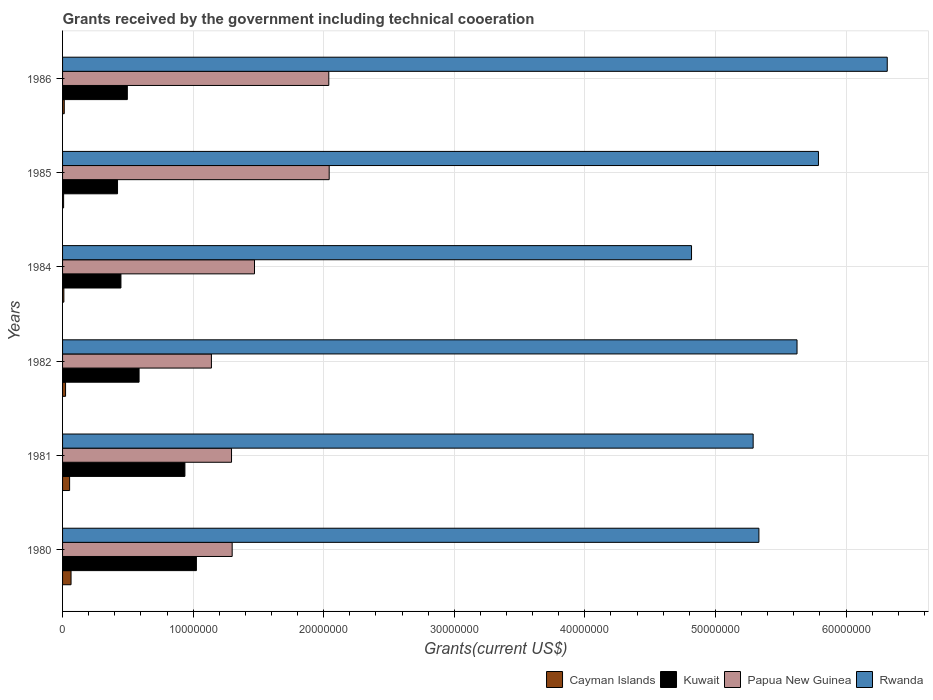Are the number of bars per tick equal to the number of legend labels?
Your response must be concise. Yes. Are the number of bars on each tick of the Y-axis equal?
Provide a short and direct response. Yes. What is the label of the 5th group of bars from the top?
Keep it short and to the point. 1981. What is the total grants received by the government in Rwanda in 1981?
Offer a terse response. 5.29e+07. Across all years, what is the maximum total grants received by the government in Kuwait?
Your answer should be compact. 1.02e+07. Across all years, what is the minimum total grants received by the government in Kuwait?
Provide a succinct answer. 4.21e+06. In which year was the total grants received by the government in Papua New Guinea maximum?
Provide a short and direct response. 1985. What is the total total grants received by the government in Cayman Islands in the graph?
Ensure brevity in your answer.  1.73e+06. What is the difference between the total grants received by the government in Kuwait in 1982 and the total grants received by the government in Cayman Islands in 1986?
Offer a very short reply. 5.73e+06. What is the average total grants received by the government in Cayman Islands per year?
Offer a terse response. 2.88e+05. In the year 1985, what is the difference between the total grants received by the government in Papua New Guinea and total grants received by the government in Kuwait?
Offer a very short reply. 1.62e+07. In how many years, is the total grants received by the government in Papua New Guinea greater than 6000000 US$?
Ensure brevity in your answer.  6. What is the ratio of the total grants received by the government in Cayman Islands in 1980 to that in 1985?
Your answer should be very brief. 8.12. Is the total grants received by the government in Papua New Guinea in 1982 less than that in 1986?
Your response must be concise. Yes. Is the difference between the total grants received by the government in Papua New Guinea in 1980 and 1985 greater than the difference between the total grants received by the government in Kuwait in 1980 and 1985?
Offer a very short reply. No. What is the difference between the highest and the second highest total grants received by the government in Rwanda?
Keep it short and to the point. 5.27e+06. What is the difference between the highest and the lowest total grants received by the government in Rwanda?
Keep it short and to the point. 1.50e+07. In how many years, is the total grants received by the government in Cayman Islands greater than the average total grants received by the government in Cayman Islands taken over all years?
Offer a terse response. 2. What does the 4th bar from the top in 1985 represents?
Offer a very short reply. Cayman Islands. What does the 3rd bar from the bottom in 1986 represents?
Offer a very short reply. Papua New Guinea. Is it the case that in every year, the sum of the total grants received by the government in Rwanda and total grants received by the government in Kuwait is greater than the total grants received by the government in Papua New Guinea?
Ensure brevity in your answer.  Yes. Does the graph contain any zero values?
Ensure brevity in your answer.  No. Does the graph contain grids?
Provide a succinct answer. Yes. Where does the legend appear in the graph?
Your response must be concise. Bottom right. How many legend labels are there?
Keep it short and to the point. 4. How are the legend labels stacked?
Ensure brevity in your answer.  Horizontal. What is the title of the graph?
Offer a very short reply. Grants received by the government including technical cooeration. What is the label or title of the X-axis?
Offer a very short reply. Grants(current US$). What is the Grants(current US$) of Cayman Islands in 1980?
Provide a succinct answer. 6.50e+05. What is the Grants(current US$) in Kuwait in 1980?
Your answer should be very brief. 1.02e+07. What is the Grants(current US$) in Papua New Guinea in 1980?
Offer a very short reply. 1.30e+07. What is the Grants(current US$) in Rwanda in 1980?
Provide a succinct answer. 5.33e+07. What is the Grants(current US$) in Cayman Islands in 1981?
Offer a very short reply. 5.40e+05. What is the Grants(current US$) in Kuwait in 1981?
Offer a terse response. 9.37e+06. What is the Grants(current US$) of Papua New Guinea in 1981?
Keep it short and to the point. 1.29e+07. What is the Grants(current US$) in Rwanda in 1981?
Your answer should be very brief. 5.29e+07. What is the Grants(current US$) in Cayman Islands in 1982?
Make the answer very short. 2.30e+05. What is the Grants(current US$) in Kuwait in 1982?
Keep it short and to the point. 5.86e+06. What is the Grants(current US$) in Papua New Guinea in 1982?
Make the answer very short. 1.14e+07. What is the Grants(current US$) of Rwanda in 1982?
Your answer should be very brief. 5.62e+07. What is the Grants(current US$) of Kuwait in 1984?
Make the answer very short. 4.47e+06. What is the Grants(current US$) of Papua New Guinea in 1984?
Provide a succinct answer. 1.47e+07. What is the Grants(current US$) in Rwanda in 1984?
Offer a terse response. 4.82e+07. What is the Grants(current US$) in Kuwait in 1985?
Offer a very short reply. 4.21e+06. What is the Grants(current US$) in Papua New Guinea in 1985?
Offer a terse response. 2.04e+07. What is the Grants(current US$) of Rwanda in 1985?
Give a very brief answer. 5.79e+07. What is the Grants(current US$) of Kuwait in 1986?
Give a very brief answer. 4.96e+06. What is the Grants(current US$) of Papua New Guinea in 1986?
Keep it short and to the point. 2.04e+07. What is the Grants(current US$) of Rwanda in 1986?
Offer a very short reply. 6.32e+07. Across all years, what is the maximum Grants(current US$) in Cayman Islands?
Your answer should be very brief. 6.50e+05. Across all years, what is the maximum Grants(current US$) in Kuwait?
Your answer should be very brief. 1.02e+07. Across all years, what is the maximum Grants(current US$) in Papua New Guinea?
Offer a very short reply. 2.04e+07. Across all years, what is the maximum Grants(current US$) in Rwanda?
Ensure brevity in your answer.  6.32e+07. Across all years, what is the minimum Grants(current US$) in Kuwait?
Your answer should be very brief. 4.21e+06. Across all years, what is the minimum Grants(current US$) of Papua New Guinea?
Provide a short and direct response. 1.14e+07. Across all years, what is the minimum Grants(current US$) of Rwanda?
Offer a terse response. 4.82e+07. What is the total Grants(current US$) in Cayman Islands in the graph?
Offer a very short reply. 1.73e+06. What is the total Grants(current US$) of Kuwait in the graph?
Your response must be concise. 3.91e+07. What is the total Grants(current US$) of Papua New Guinea in the graph?
Your response must be concise. 9.28e+07. What is the total Grants(current US$) of Rwanda in the graph?
Provide a short and direct response. 3.32e+08. What is the difference between the Grants(current US$) in Kuwait in 1980 and that in 1981?
Ensure brevity in your answer.  8.80e+05. What is the difference between the Grants(current US$) of Cayman Islands in 1980 and that in 1982?
Your answer should be compact. 4.20e+05. What is the difference between the Grants(current US$) of Kuwait in 1980 and that in 1982?
Your answer should be very brief. 4.39e+06. What is the difference between the Grants(current US$) of Papua New Guinea in 1980 and that in 1982?
Provide a short and direct response. 1.59e+06. What is the difference between the Grants(current US$) of Rwanda in 1980 and that in 1982?
Provide a short and direct response. -2.92e+06. What is the difference between the Grants(current US$) in Cayman Islands in 1980 and that in 1984?
Offer a very short reply. 5.50e+05. What is the difference between the Grants(current US$) in Kuwait in 1980 and that in 1984?
Provide a short and direct response. 5.78e+06. What is the difference between the Grants(current US$) of Papua New Guinea in 1980 and that in 1984?
Make the answer very short. -1.71e+06. What is the difference between the Grants(current US$) in Rwanda in 1980 and that in 1984?
Ensure brevity in your answer.  5.16e+06. What is the difference between the Grants(current US$) in Cayman Islands in 1980 and that in 1985?
Offer a very short reply. 5.70e+05. What is the difference between the Grants(current US$) in Kuwait in 1980 and that in 1985?
Your answer should be very brief. 6.04e+06. What is the difference between the Grants(current US$) in Papua New Guinea in 1980 and that in 1985?
Your response must be concise. -7.43e+06. What is the difference between the Grants(current US$) in Rwanda in 1980 and that in 1985?
Provide a short and direct response. -4.56e+06. What is the difference between the Grants(current US$) in Cayman Islands in 1980 and that in 1986?
Offer a very short reply. 5.20e+05. What is the difference between the Grants(current US$) in Kuwait in 1980 and that in 1986?
Your answer should be compact. 5.29e+06. What is the difference between the Grants(current US$) of Papua New Guinea in 1980 and that in 1986?
Provide a short and direct response. -7.40e+06. What is the difference between the Grants(current US$) in Rwanda in 1980 and that in 1986?
Your answer should be very brief. -9.83e+06. What is the difference between the Grants(current US$) in Kuwait in 1981 and that in 1982?
Ensure brevity in your answer.  3.51e+06. What is the difference between the Grants(current US$) in Papua New Guinea in 1981 and that in 1982?
Keep it short and to the point. 1.54e+06. What is the difference between the Grants(current US$) in Rwanda in 1981 and that in 1982?
Your answer should be very brief. -3.36e+06. What is the difference between the Grants(current US$) of Kuwait in 1981 and that in 1984?
Provide a short and direct response. 4.90e+06. What is the difference between the Grants(current US$) of Papua New Guinea in 1981 and that in 1984?
Your answer should be compact. -1.76e+06. What is the difference between the Grants(current US$) of Rwanda in 1981 and that in 1984?
Ensure brevity in your answer.  4.72e+06. What is the difference between the Grants(current US$) of Kuwait in 1981 and that in 1985?
Make the answer very short. 5.16e+06. What is the difference between the Grants(current US$) of Papua New Guinea in 1981 and that in 1985?
Your answer should be very brief. -7.48e+06. What is the difference between the Grants(current US$) in Rwanda in 1981 and that in 1985?
Provide a short and direct response. -5.00e+06. What is the difference between the Grants(current US$) of Cayman Islands in 1981 and that in 1986?
Make the answer very short. 4.10e+05. What is the difference between the Grants(current US$) in Kuwait in 1981 and that in 1986?
Your answer should be very brief. 4.41e+06. What is the difference between the Grants(current US$) in Papua New Guinea in 1981 and that in 1986?
Your answer should be very brief. -7.45e+06. What is the difference between the Grants(current US$) of Rwanda in 1981 and that in 1986?
Your answer should be compact. -1.03e+07. What is the difference between the Grants(current US$) in Cayman Islands in 1982 and that in 1984?
Offer a very short reply. 1.30e+05. What is the difference between the Grants(current US$) of Kuwait in 1982 and that in 1984?
Your answer should be compact. 1.39e+06. What is the difference between the Grants(current US$) of Papua New Guinea in 1982 and that in 1984?
Offer a terse response. -3.30e+06. What is the difference between the Grants(current US$) of Rwanda in 1982 and that in 1984?
Your answer should be very brief. 8.08e+06. What is the difference between the Grants(current US$) in Cayman Islands in 1982 and that in 1985?
Ensure brevity in your answer.  1.50e+05. What is the difference between the Grants(current US$) in Kuwait in 1982 and that in 1985?
Offer a terse response. 1.65e+06. What is the difference between the Grants(current US$) in Papua New Guinea in 1982 and that in 1985?
Provide a succinct answer. -9.02e+06. What is the difference between the Grants(current US$) in Rwanda in 1982 and that in 1985?
Offer a very short reply. -1.64e+06. What is the difference between the Grants(current US$) of Kuwait in 1982 and that in 1986?
Offer a terse response. 9.00e+05. What is the difference between the Grants(current US$) in Papua New Guinea in 1982 and that in 1986?
Offer a very short reply. -8.99e+06. What is the difference between the Grants(current US$) of Rwanda in 1982 and that in 1986?
Offer a very short reply. -6.91e+06. What is the difference between the Grants(current US$) of Papua New Guinea in 1984 and that in 1985?
Provide a succinct answer. -5.72e+06. What is the difference between the Grants(current US$) of Rwanda in 1984 and that in 1985?
Make the answer very short. -9.72e+06. What is the difference between the Grants(current US$) in Kuwait in 1984 and that in 1986?
Provide a short and direct response. -4.90e+05. What is the difference between the Grants(current US$) in Papua New Guinea in 1984 and that in 1986?
Your answer should be compact. -5.69e+06. What is the difference between the Grants(current US$) in Rwanda in 1984 and that in 1986?
Your response must be concise. -1.50e+07. What is the difference between the Grants(current US$) of Cayman Islands in 1985 and that in 1986?
Make the answer very short. -5.00e+04. What is the difference between the Grants(current US$) in Kuwait in 1985 and that in 1986?
Make the answer very short. -7.50e+05. What is the difference between the Grants(current US$) in Rwanda in 1985 and that in 1986?
Make the answer very short. -5.27e+06. What is the difference between the Grants(current US$) in Cayman Islands in 1980 and the Grants(current US$) in Kuwait in 1981?
Offer a very short reply. -8.72e+06. What is the difference between the Grants(current US$) in Cayman Islands in 1980 and the Grants(current US$) in Papua New Guinea in 1981?
Keep it short and to the point. -1.23e+07. What is the difference between the Grants(current US$) in Cayman Islands in 1980 and the Grants(current US$) in Rwanda in 1981?
Provide a succinct answer. -5.22e+07. What is the difference between the Grants(current US$) in Kuwait in 1980 and the Grants(current US$) in Papua New Guinea in 1981?
Give a very brief answer. -2.69e+06. What is the difference between the Grants(current US$) of Kuwait in 1980 and the Grants(current US$) of Rwanda in 1981?
Give a very brief answer. -4.26e+07. What is the difference between the Grants(current US$) of Papua New Guinea in 1980 and the Grants(current US$) of Rwanda in 1981?
Provide a short and direct response. -3.99e+07. What is the difference between the Grants(current US$) of Cayman Islands in 1980 and the Grants(current US$) of Kuwait in 1982?
Provide a short and direct response. -5.21e+06. What is the difference between the Grants(current US$) in Cayman Islands in 1980 and the Grants(current US$) in Papua New Guinea in 1982?
Your response must be concise. -1.08e+07. What is the difference between the Grants(current US$) of Cayman Islands in 1980 and the Grants(current US$) of Rwanda in 1982?
Your answer should be compact. -5.56e+07. What is the difference between the Grants(current US$) of Kuwait in 1980 and the Grants(current US$) of Papua New Guinea in 1982?
Give a very brief answer. -1.15e+06. What is the difference between the Grants(current US$) of Kuwait in 1980 and the Grants(current US$) of Rwanda in 1982?
Your answer should be compact. -4.60e+07. What is the difference between the Grants(current US$) in Papua New Guinea in 1980 and the Grants(current US$) in Rwanda in 1982?
Provide a short and direct response. -4.33e+07. What is the difference between the Grants(current US$) of Cayman Islands in 1980 and the Grants(current US$) of Kuwait in 1984?
Make the answer very short. -3.82e+06. What is the difference between the Grants(current US$) in Cayman Islands in 1980 and the Grants(current US$) in Papua New Guinea in 1984?
Offer a very short reply. -1.40e+07. What is the difference between the Grants(current US$) of Cayman Islands in 1980 and the Grants(current US$) of Rwanda in 1984?
Provide a succinct answer. -4.75e+07. What is the difference between the Grants(current US$) of Kuwait in 1980 and the Grants(current US$) of Papua New Guinea in 1984?
Give a very brief answer. -4.45e+06. What is the difference between the Grants(current US$) in Kuwait in 1980 and the Grants(current US$) in Rwanda in 1984?
Offer a very short reply. -3.79e+07. What is the difference between the Grants(current US$) in Papua New Guinea in 1980 and the Grants(current US$) in Rwanda in 1984?
Your response must be concise. -3.52e+07. What is the difference between the Grants(current US$) of Cayman Islands in 1980 and the Grants(current US$) of Kuwait in 1985?
Provide a short and direct response. -3.56e+06. What is the difference between the Grants(current US$) of Cayman Islands in 1980 and the Grants(current US$) of Papua New Guinea in 1985?
Make the answer very short. -1.98e+07. What is the difference between the Grants(current US$) of Cayman Islands in 1980 and the Grants(current US$) of Rwanda in 1985?
Offer a terse response. -5.72e+07. What is the difference between the Grants(current US$) in Kuwait in 1980 and the Grants(current US$) in Papua New Guinea in 1985?
Your answer should be compact. -1.02e+07. What is the difference between the Grants(current US$) of Kuwait in 1980 and the Grants(current US$) of Rwanda in 1985?
Give a very brief answer. -4.76e+07. What is the difference between the Grants(current US$) in Papua New Guinea in 1980 and the Grants(current US$) in Rwanda in 1985?
Make the answer very short. -4.49e+07. What is the difference between the Grants(current US$) of Cayman Islands in 1980 and the Grants(current US$) of Kuwait in 1986?
Make the answer very short. -4.31e+06. What is the difference between the Grants(current US$) of Cayman Islands in 1980 and the Grants(current US$) of Papua New Guinea in 1986?
Your response must be concise. -1.97e+07. What is the difference between the Grants(current US$) in Cayman Islands in 1980 and the Grants(current US$) in Rwanda in 1986?
Offer a very short reply. -6.25e+07. What is the difference between the Grants(current US$) in Kuwait in 1980 and the Grants(current US$) in Papua New Guinea in 1986?
Give a very brief answer. -1.01e+07. What is the difference between the Grants(current US$) of Kuwait in 1980 and the Grants(current US$) of Rwanda in 1986?
Offer a terse response. -5.29e+07. What is the difference between the Grants(current US$) of Papua New Guinea in 1980 and the Grants(current US$) of Rwanda in 1986?
Provide a succinct answer. -5.02e+07. What is the difference between the Grants(current US$) in Cayman Islands in 1981 and the Grants(current US$) in Kuwait in 1982?
Offer a terse response. -5.32e+06. What is the difference between the Grants(current US$) in Cayman Islands in 1981 and the Grants(current US$) in Papua New Guinea in 1982?
Provide a succinct answer. -1.09e+07. What is the difference between the Grants(current US$) in Cayman Islands in 1981 and the Grants(current US$) in Rwanda in 1982?
Your answer should be very brief. -5.57e+07. What is the difference between the Grants(current US$) in Kuwait in 1981 and the Grants(current US$) in Papua New Guinea in 1982?
Keep it short and to the point. -2.03e+06. What is the difference between the Grants(current US$) of Kuwait in 1981 and the Grants(current US$) of Rwanda in 1982?
Your answer should be very brief. -4.69e+07. What is the difference between the Grants(current US$) in Papua New Guinea in 1981 and the Grants(current US$) in Rwanda in 1982?
Offer a very short reply. -4.33e+07. What is the difference between the Grants(current US$) in Cayman Islands in 1981 and the Grants(current US$) in Kuwait in 1984?
Ensure brevity in your answer.  -3.93e+06. What is the difference between the Grants(current US$) in Cayman Islands in 1981 and the Grants(current US$) in Papua New Guinea in 1984?
Keep it short and to the point. -1.42e+07. What is the difference between the Grants(current US$) of Cayman Islands in 1981 and the Grants(current US$) of Rwanda in 1984?
Your answer should be very brief. -4.76e+07. What is the difference between the Grants(current US$) in Kuwait in 1981 and the Grants(current US$) in Papua New Guinea in 1984?
Offer a terse response. -5.33e+06. What is the difference between the Grants(current US$) of Kuwait in 1981 and the Grants(current US$) of Rwanda in 1984?
Provide a short and direct response. -3.88e+07. What is the difference between the Grants(current US$) in Papua New Guinea in 1981 and the Grants(current US$) in Rwanda in 1984?
Your response must be concise. -3.52e+07. What is the difference between the Grants(current US$) of Cayman Islands in 1981 and the Grants(current US$) of Kuwait in 1985?
Provide a short and direct response. -3.67e+06. What is the difference between the Grants(current US$) of Cayman Islands in 1981 and the Grants(current US$) of Papua New Guinea in 1985?
Make the answer very short. -1.99e+07. What is the difference between the Grants(current US$) of Cayman Islands in 1981 and the Grants(current US$) of Rwanda in 1985?
Give a very brief answer. -5.74e+07. What is the difference between the Grants(current US$) of Kuwait in 1981 and the Grants(current US$) of Papua New Guinea in 1985?
Provide a succinct answer. -1.10e+07. What is the difference between the Grants(current US$) of Kuwait in 1981 and the Grants(current US$) of Rwanda in 1985?
Make the answer very short. -4.85e+07. What is the difference between the Grants(current US$) in Papua New Guinea in 1981 and the Grants(current US$) in Rwanda in 1985?
Keep it short and to the point. -4.50e+07. What is the difference between the Grants(current US$) in Cayman Islands in 1981 and the Grants(current US$) in Kuwait in 1986?
Give a very brief answer. -4.42e+06. What is the difference between the Grants(current US$) of Cayman Islands in 1981 and the Grants(current US$) of Papua New Guinea in 1986?
Your response must be concise. -1.98e+07. What is the difference between the Grants(current US$) in Cayman Islands in 1981 and the Grants(current US$) in Rwanda in 1986?
Provide a short and direct response. -6.26e+07. What is the difference between the Grants(current US$) in Kuwait in 1981 and the Grants(current US$) in Papua New Guinea in 1986?
Give a very brief answer. -1.10e+07. What is the difference between the Grants(current US$) of Kuwait in 1981 and the Grants(current US$) of Rwanda in 1986?
Ensure brevity in your answer.  -5.38e+07. What is the difference between the Grants(current US$) of Papua New Guinea in 1981 and the Grants(current US$) of Rwanda in 1986?
Your answer should be compact. -5.02e+07. What is the difference between the Grants(current US$) in Cayman Islands in 1982 and the Grants(current US$) in Kuwait in 1984?
Your response must be concise. -4.24e+06. What is the difference between the Grants(current US$) of Cayman Islands in 1982 and the Grants(current US$) of Papua New Guinea in 1984?
Make the answer very short. -1.45e+07. What is the difference between the Grants(current US$) in Cayman Islands in 1982 and the Grants(current US$) in Rwanda in 1984?
Provide a succinct answer. -4.79e+07. What is the difference between the Grants(current US$) of Kuwait in 1982 and the Grants(current US$) of Papua New Guinea in 1984?
Your answer should be compact. -8.84e+06. What is the difference between the Grants(current US$) in Kuwait in 1982 and the Grants(current US$) in Rwanda in 1984?
Offer a terse response. -4.23e+07. What is the difference between the Grants(current US$) of Papua New Guinea in 1982 and the Grants(current US$) of Rwanda in 1984?
Your answer should be compact. -3.68e+07. What is the difference between the Grants(current US$) in Cayman Islands in 1982 and the Grants(current US$) in Kuwait in 1985?
Your answer should be very brief. -3.98e+06. What is the difference between the Grants(current US$) in Cayman Islands in 1982 and the Grants(current US$) in Papua New Guinea in 1985?
Your answer should be very brief. -2.02e+07. What is the difference between the Grants(current US$) in Cayman Islands in 1982 and the Grants(current US$) in Rwanda in 1985?
Your response must be concise. -5.77e+07. What is the difference between the Grants(current US$) in Kuwait in 1982 and the Grants(current US$) in Papua New Guinea in 1985?
Make the answer very short. -1.46e+07. What is the difference between the Grants(current US$) in Kuwait in 1982 and the Grants(current US$) in Rwanda in 1985?
Give a very brief answer. -5.20e+07. What is the difference between the Grants(current US$) in Papua New Guinea in 1982 and the Grants(current US$) in Rwanda in 1985?
Provide a short and direct response. -4.65e+07. What is the difference between the Grants(current US$) in Cayman Islands in 1982 and the Grants(current US$) in Kuwait in 1986?
Make the answer very short. -4.73e+06. What is the difference between the Grants(current US$) in Cayman Islands in 1982 and the Grants(current US$) in Papua New Guinea in 1986?
Provide a short and direct response. -2.02e+07. What is the difference between the Grants(current US$) in Cayman Islands in 1982 and the Grants(current US$) in Rwanda in 1986?
Provide a succinct answer. -6.29e+07. What is the difference between the Grants(current US$) in Kuwait in 1982 and the Grants(current US$) in Papua New Guinea in 1986?
Your answer should be very brief. -1.45e+07. What is the difference between the Grants(current US$) of Kuwait in 1982 and the Grants(current US$) of Rwanda in 1986?
Ensure brevity in your answer.  -5.73e+07. What is the difference between the Grants(current US$) of Papua New Guinea in 1982 and the Grants(current US$) of Rwanda in 1986?
Ensure brevity in your answer.  -5.18e+07. What is the difference between the Grants(current US$) of Cayman Islands in 1984 and the Grants(current US$) of Kuwait in 1985?
Your answer should be compact. -4.11e+06. What is the difference between the Grants(current US$) of Cayman Islands in 1984 and the Grants(current US$) of Papua New Guinea in 1985?
Keep it short and to the point. -2.03e+07. What is the difference between the Grants(current US$) of Cayman Islands in 1984 and the Grants(current US$) of Rwanda in 1985?
Offer a terse response. -5.78e+07. What is the difference between the Grants(current US$) in Kuwait in 1984 and the Grants(current US$) in Papua New Guinea in 1985?
Keep it short and to the point. -1.60e+07. What is the difference between the Grants(current US$) in Kuwait in 1984 and the Grants(current US$) in Rwanda in 1985?
Provide a succinct answer. -5.34e+07. What is the difference between the Grants(current US$) in Papua New Guinea in 1984 and the Grants(current US$) in Rwanda in 1985?
Keep it short and to the point. -4.32e+07. What is the difference between the Grants(current US$) in Cayman Islands in 1984 and the Grants(current US$) in Kuwait in 1986?
Your answer should be compact. -4.86e+06. What is the difference between the Grants(current US$) of Cayman Islands in 1984 and the Grants(current US$) of Papua New Guinea in 1986?
Your answer should be compact. -2.03e+07. What is the difference between the Grants(current US$) in Cayman Islands in 1984 and the Grants(current US$) in Rwanda in 1986?
Keep it short and to the point. -6.31e+07. What is the difference between the Grants(current US$) of Kuwait in 1984 and the Grants(current US$) of Papua New Guinea in 1986?
Offer a terse response. -1.59e+07. What is the difference between the Grants(current US$) of Kuwait in 1984 and the Grants(current US$) of Rwanda in 1986?
Make the answer very short. -5.87e+07. What is the difference between the Grants(current US$) of Papua New Guinea in 1984 and the Grants(current US$) of Rwanda in 1986?
Ensure brevity in your answer.  -4.85e+07. What is the difference between the Grants(current US$) of Cayman Islands in 1985 and the Grants(current US$) of Kuwait in 1986?
Make the answer very short. -4.88e+06. What is the difference between the Grants(current US$) in Cayman Islands in 1985 and the Grants(current US$) in Papua New Guinea in 1986?
Keep it short and to the point. -2.03e+07. What is the difference between the Grants(current US$) of Cayman Islands in 1985 and the Grants(current US$) of Rwanda in 1986?
Your response must be concise. -6.31e+07. What is the difference between the Grants(current US$) of Kuwait in 1985 and the Grants(current US$) of Papua New Guinea in 1986?
Ensure brevity in your answer.  -1.62e+07. What is the difference between the Grants(current US$) in Kuwait in 1985 and the Grants(current US$) in Rwanda in 1986?
Ensure brevity in your answer.  -5.90e+07. What is the difference between the Grants(current US$) in Papua New Guinea in 1985 and the Grants(current US$) in Rwanda in 1986?
Offer a very short reply. -4.27e+07. What is the average Grants(current US$) in Cayman Islands per year?
Your answer should be very brief. 2.88e+05. What is the average Grants(current US$) of Kuwait per year?
Keep it short and to the point. 6.52e+06. What is the average Grants(current US$) of Papua New Guinea per year?
Your answer should be very brief. 1.55e+07. What is the average Grants(current US$) in Rwanda per year?
Your response must be concise. 5.53e+07. In the year 1980, what is the difference between the Grants(current US$) of Cayman Islands and Grants(current US$) of Kuwait?
Your response must be concise. -9.60e+06. In the year 1980, what is the difference between the Grants(current US$) in Cayman Islands and Grants(current US$) in Papua New Guinea?
Keep it short and to the point. -1.23e+07. In the year 1980, what is the difference between the Grants(current US$) of Cayman Islands and Grants(current US$) of Rwanda?
Make the answer very short. -5.27e+07. In the year 1980, what is the difference between the Grants(current US$) of Kuwait and Grants(current US$) of Papua New Guinea?
Provide a short and direct response. -2.74e+06. In the year 1980, what is the difference between the Grants(current US$) of Kuwait and Grants(current US$) of Rwanda?
Keep it short and to the point. -4.31e+07. In the year 1980, what is the difference between the Grants(current US$) of Papua New Guinea and Grants(current US$) of Rwanda?
Offer a very short reply. -4.03e+07. In the year 1981, what is the difference between the Grants(current US$) in Cayman Islands and Grants(current US$) in Kuwait?
Offer a very short reply. -8.83e+06. In the year 1981, what is the difference between the Grants(current US$) of Cayman Islands and Grants(current US$) of Papua New Guinea?
Provide a succinct answer. -1.24e+07. In the year 1981, what is the difference between the Grants(current US$) of Cayman Islands and Grants(current US$) of Rwanda?
Give a very brief answer. -5.24e+07. In the year 1981, what is the difference between the Grants(current US$) in Kuwait and Grants(current US$) in Papua New Guinea?
Offer a terse response. -3.57e+06. In the year 1981, what is the difference between the Grants(current US$) in Kuwait and Grants(current US$) in Rwanda?
Make the answer very short. -4.35e+07. In the year 1981, what is the difference between the Grants(current US$) in Papua New Guinea and Grants(current US$) in Rwanda?
Your response must be concise. -4.00e+07. In the year 1982, what is the difference between the Grants(current US$) of Cayman Islands and Grants(current US$) of Kuwait?
Provide a short and direct response. -5.63e+06. In the year 1982, what is the difference between the Grants(current US$) in Cayman Islands and Grants(current US$) in Papua New Guinea?
Give a very brief answer. -1.12e+07. In the year 1982, what is the difference between the Grants(current US$) of Cayman Islands and Grants(current US$) of Rwanda?
Your response must be concise. -5.60e+07. In the year 1982, what is the difference between the Grants(current US$) in Kuwait and Grants(current US$) in Papua New Guinea?
Make the answer very short. -5.54e+06. In the year 1982, what is the difference between the Grants(current US$) of Kuwait and Grants(current US$) of Rwanda?
Offer a very short reply. -5.04e+07. In the year 1982, what is the difference between the Grants(current US$) of Papua New Guinea and Grants(current US$) of Rwanda?
Ensure brevity in your answer.  -4.48e+07. In the year 1984, what is the difference between the Grants(current US$) in Cayman Islands and Grants(current US$) in Kuwait?
Offer a terse response. -4.37e+06. In the year 1984, what is the difference between the Grants(current US$) of Cayman Islands and Grants(current US$) of Papua New Guinea?
Provide a short and direct response. -1.46e+07. In the year 1984, what is the difference between the Grants(current US$) in Cayman Islands and Grants(current US$) in Rwanda?
Give a very brief answer. -4.81e+07. In the year 1984, what is the difference between the Grants(current US$) of Kuwait and Grants(current US$) of Papua New Guinea?
Provide a short and direct response. -1.02e+07. In the year 1984, what is the difference between the Grants(current US$) in Kuwait and Grants(current US$) in Rwanda?
Ensure brevity in your answer.  -4.37e+07. In the year 1984, what is the difference between the Grants(current US$) in Papua New Guinea and Grants(current US$) in Rwanda?
Keep it short and to the point. -3.35e+07. In the year 1985, what is the difference between the Grants(current US$) in Cayman Islands and Grants(current US$) in Kuwait?
Your answer should be compact. -4.13e+06. In the year 1985, what is the difference between the Grants(current US$) of Cayman Islands and Grants(current US$) of Papua New Guinea?
Provide a succinct answer. -2.03e+07. In the year 1985, what is the difference between the Grants(current US$) of Cayman Islands and Grants(current US$) of Rwanda?
Your answer should be compact. -5.78e+07. In the year 1985, what is the difference between the Grants(current US$) in Kuwait and Grants(current US$) in Papua New Guinea?
Your answer should be very brief. -1.62e+07. In the year 1985, what is the difference between the Grants(current US$) in Kuwait and Grants(current US$) in Rwanda?
Provide a succinct answer. -5.37e+07. In the year 1985, what is the difference between the Grants(current US$) in Papua New Guinea and Grants(current US$) in Rwanda?
Your response must be concise. -3.75e+07. In the year 1986, what is the difference between the Grants(current US$) of Cayman Islands and Grants(current US$) of Kuwait?
Give a very brief answer. -4.83e+06. In the year 1986, what is the difference between the Grants(current US$) in Cayman Islands and Grants(current US$) in Papua New Guinea?
Your answer should be very brief. -2.03e+07. In the year 1986, what is the difference between the Grants(current US$) of Cayman Islands and Grants(current US$) of Rwanda?
Offer a terse response. -6.30e+07. In the year 1986, what is the difference between the Grants(current US$) in Kuwait and Grants(current US$) in Papua New Guinea?
Make the answer very short. -1.54e+07. In the year 1986, what is the difference between the Grants(current US$) in Kuwait and Grants(current US$) in Rwanda?
Your response must be concise. -5.82e+07. In the year 1986, what is the difference between the Grants(current US$) in Papua New Guinea and Grants(current US$) in Rwanda?
Your answer should be compact. -4.28e+07. What is the ratio of the Grants(current US$) of Cayman Islands in 1980 to that in 1981?
Make the answer very short. 1.2. What is the ratio of the Grants(current US$) in Kuwait in 1980 to that in 1981?
Your response must be concise. 1.09. What is the ratio of the Grants(current US$) of Papua New Guinea in 1980 to that in 1981?
Offer a very short reply. 1. What is the ratio of the Grants(current US$) in Rwanda in 1980 to that in 1981?
Offer a terse response. 1.01. What is the ratio of the Grants(current US$) in Cayman Islands in 1980 to that in 1982?
Ensure brevity in your answer.  2.83. What is the ratio of the Grants(current US$) of Kuwait in 1980 to that in 1982?
Your response must be concise. 1.75. What is the ratio of the Grants(current US$) of Papua New Guinea in 1980 to that in 1982?
Provide a short and direct response. 1.14. What is the ratio of the Grants(current US$) in Rwanda in 1980 to that in 1982?
Your answer should be compact. 0.95. What is the ratio of the Grants(current US$) in Cayman Islands in 1980 to that in 1984?
Keep it short and to the point. 6.5. What is the ratio of the Grants(current US$) of Kuwait in 1980 to that in 1984?
Give a very brief answer. 2.29. What is the ratio of the Grants(current US$) of Papua New Guinea in 1980 to that in 1984?
Provide a succinct answer. 0.88. What is the ratio of the Grants(current US$) of Rwanda in 1980 to that in 1984?
Your response must be concise. 1.11. What is the ratio of the Grants(current US$) in Cayman Islands in 1980 to that in 1985?
Ensure brevity in your answer.  8.12. What is the ratio of the Grants(current US$) in Kuwait in 1980 to that in 1985?
Provide a succinct answer. 2.43. What is the ratio of the Grants(current US$) in Papua New Guinea in 1980 to that in 1985?
Your answer should be very brief. 0.64. What is the ratio of the Grants(current US$) of Rwanda in 1980 to that in 1985?
Make the answer very short. 0.92. What is the ratio of the Grants(current US$) of Cayman Islands in 1980 to that in 1986?
Your answer should be very brief. 5. What is the ratio of the Grants(current US$) of Kuwait in 1980 to that in 1986?
Your response must be concise. 2.07. What is the ratio of the Grants(current US$) of Papua New Guinea in 1980 to that in 1986?
Ensure brevity in your answer.  0.64. What is the ratio of the Grants(current US$) of Rwanda in 1980 to that in 1986?
Provide a short and direct response. 0.84. What is the ratio of the Grants(current US$) of Cayman Islands in 1981 to that in 1982?
Keep it short and to the point. 2.35. What is the ratio of the Grants(current US$) in Kuwait in 1981 to that in 1982?
Ensure brevity in your answer.  1.6. What is the ratio of the Grants(current US$) in Papua New Guinea in 1981 to that in 1982?
Your answer should be compact. 1.14. What is the ratio of the Grants(current US$) of Rwanda in 1981 to that in 1982?
Your answer should be very brief. 0.94. What is the ratio of the Grants(current US$) of Kuwait in 1981 to that in 1984?
Provide a succinct answer. 2.1. What is the ratio of the Grants(current US$) of Papua New Guinea in 1981 to that in 1984?
Your response must be concise. 0.88. What is the ratio of the Grants(current US$) of Rwanda in 1981 to that in 1984?
Keep it short and to the point. 1.1. What is the ratio of the Grants(current US$) of Cayman Islands in 1981 to that in 1985?
Your response must be concise. 6.75. What is the ratio of the Grants(current US$) in Kuwait in 1981 to that in 1985?
Provide a short and direct response. 2.23. What is the ratio of the Grants(current US$) in Papua New Guinea in 1981 to that in 1985?
Provide a succinct answer. 0.63. What is the ratio of the Grants(current US$) in Rwanda in 1981 to that in 1985?
Your answer should be compact. 0.91. What is the ratio of the Grants(current US$) of Cayman Islands in 1981 to that in 1986?
Your answer should be compact. 4.15. What is the ratio of the Grants(current US$) of Kuwait in 1981 to that in 1986?
Make the answer very short. 1.89. What is the ratio of the Grants(current US$) of Papua New Guinea in 1981 to that in 1986?
Provide a succinct answer. 0.63. What is the ratio of the Grants(current US$) in Rwanda in 1981 to that in 1986?
Your response must be concise. 0.84. What is the ratio of the Grants(current US$) of Kuwait in 1982 to that in 1984?
Keep it short and to the point. 1.31. What is the ratio of the Grants(current US$) of Papua New Guinea in 1982 to that in 1984?
Offer a terse response. 0.78. What is the ratio of the Grants(current US$) in Rwanda in 1982 to that in 1984?
Offer a very short reply. 1.17. What is the ratio of the Grants(current US$) in Cayman Islands in 1982 to that in 1985?
Make the answer very short. 2.88. What is the ratio of the Grants(current US$) in Kuwait in 1982 to that in 1985?
Your answer should be compact. 1.39. What is the ratio of the Grants(current US$) of Papua New Guinea in 1982 to that in 1985?
Keep it short and to the point. 0.56. What is the ratio of the Grants(current US$) of Rwanda in 1982 to that in 1985?
Give a very brief answer. 0.97. What is the ratio of the Grants(current US$) in Cayman Islands in 1982 to that in 1986?
Provide a short and direct response. 1.77. What is the ratio of the Grants(current US$) in Kuwait in 1982 to that in 1986?
Offer a very short reply. 1.18. What is the ratio of the Grants(current US$) in Papua New Guinea in 1982 to that in 1986?
Your answer should be compact. 0.56. What is the ratio of the Grants(current US$) in Rwanda in 1982 to that in 1986?
Make the answer very short. 0.89. What is the ratio of the Grants(current US$) of Cayman Islands in 1984 to that in 1985?
Give a very brief answer. 1.25. What is the ratio of the Grants(current US$) of Kuwait in 1984 to that in 1985?
Keep it short and to the point. 1.06. What is the ratio of the Grants(current US$) in Papua New Guinea in 1984 to that in 1985?
Your response must be concise. 0.72. What is the ratio of the Grants(current US$) of Rwanda in 1984 to that in 1985?
Give a very brief answer. 0.83. What is the ratio of the Grants(current US$) in Cayman Islands in 1984 to that in 1986?
Offer a terse response. 0.77. What is the ratio of the Grants(current US$) in Kuwait in 1984 to that in 1986?
Keep it short and to the point. 0.9. What is the ratio of the Grants(current US$) in Papua New Guinea in 1984 to that in 1986?
Keep it short and to the point. 0.72. What is the ratio of the Grants(current US$) of Rwanda in 1984 to that in 1986?
Offer a terse response. 0.76. What is the ratio of the Grants(current US$) in Cayman Islands in 1985 to that in 1986?
Make the answer very short. 0.62. What is the ratio of the Grants(current US$) in Kuwait in 1985 to that in 1986?
Offer a terse response. 0.85. What is the ratio of the Grants(current US$) of Rwanda in 1985 to that in 1986?
Offer a very short reply. 0.92. What is the difference between the highest and the second highest Grants(current US$) of Kuwait?
Ensure brevity in your answer.  8.80e+05. What is the difference between the highest and the second highest Grants(current US$) of Papua New Guinea?
Ensure brevity in your answer.  3.00e+04. What is the difference between the highest and the second highest Grants(current US$) of Rwanda?
Make the answer very short. 5.27e+06. What is the difference between the highest and the lowest Grants(current US$) in Cayman Islands?
Make the answer very short. 5.70e+05. What is the difference between the highest and the lowest Grants(current US$) in Kuwait?
Your answer should be very brief. 6.04e+06. What is the difference between the highest and the lowest Grants(current US$) in Papua New Guinea?
Keep it short and to the point. 9.02e+06. What is the difference between the highest and the lowest Grants(current US$) of Rwanda?
Keep it short and to the point. 1.50e+07. 